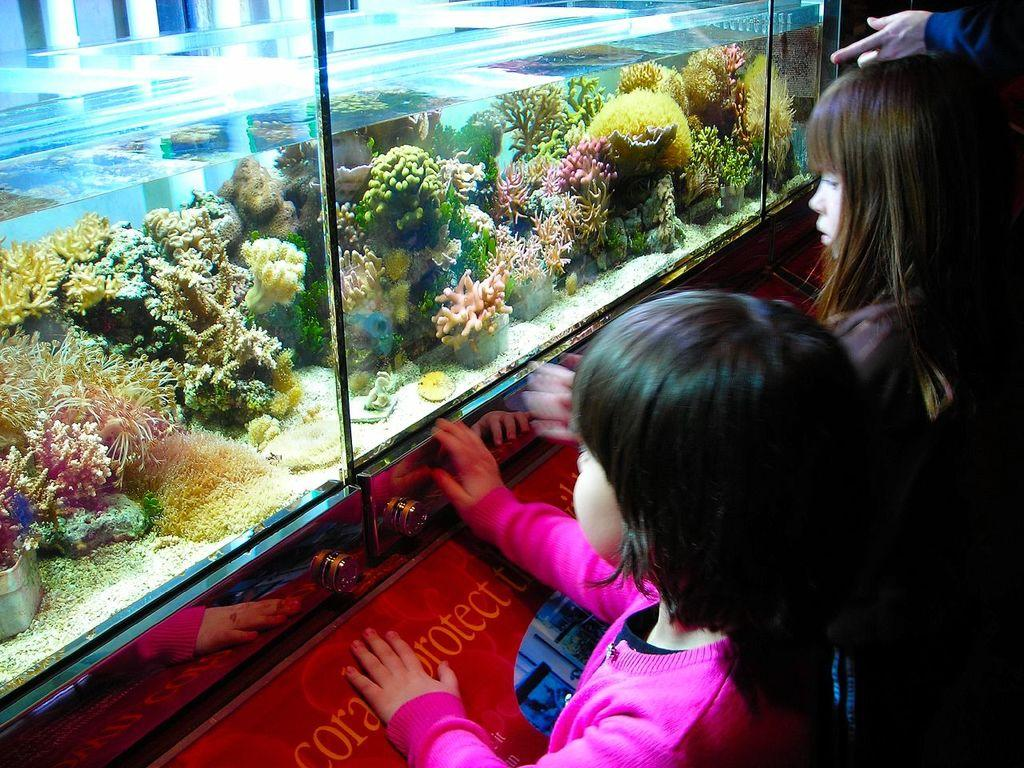How many kids are present in the image? There are kids in the image. What are the kids standing near? The kids are standing near an aquarium. What can be found inside the aquarium? There is water, flowers, and water plants in the aquarium. What type of cable can be seen hanging from the aquarium in the image? There is no cable hanging from the aquarium in the image. 